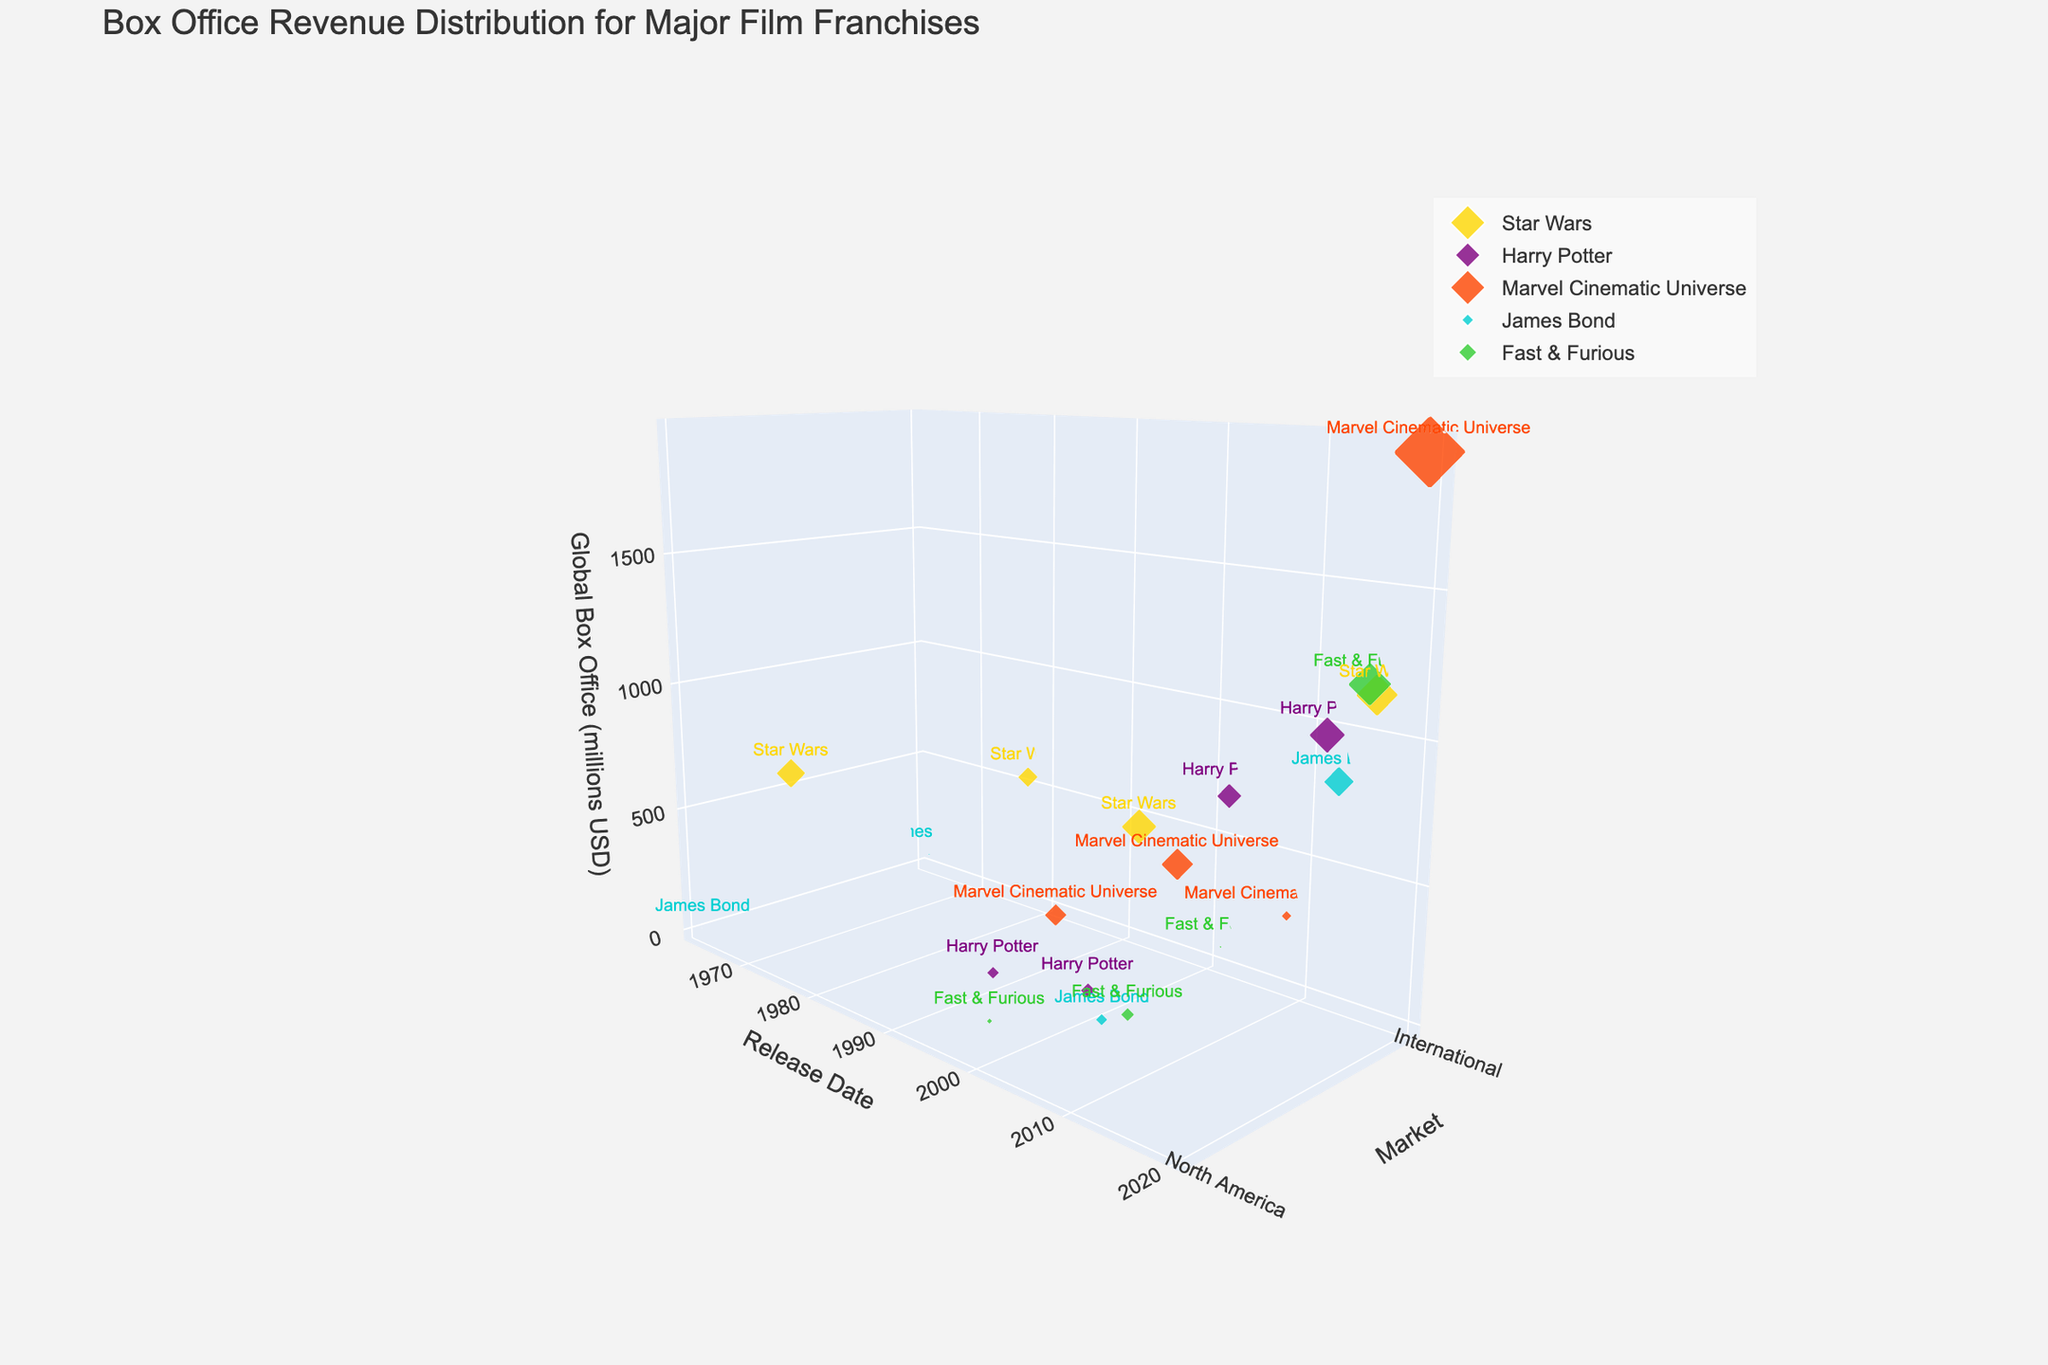What's the title of the figure? The title is typically placed at the top and is often larger than other text. It provides a summary of what the plot represents.
Answer: Box Office Revenue Distribution for Major Film Franchises What are the axes labels in the figure? The labels are usually placed next to the corresponding axes. They describe what each axis represents.
Answer: Release Date, Market, Global Box Office (millions USD) Which franchise has the highest global box office revenue in the "International" market based on the figure? By observing the 'z' axis (Global Box Office) and checking which franchise's marker reaches the highest point in the "International" market on the 'y' axis, we can determine this.
Answer: Marvel Cinematic Universe How many data points are there for "Harry Potter"? Each distinct marker in the plot represents a data point. Count the number of markers labeled "Harry Potter".
Answer: Four What is the color of the marker representing "Star Wars"? Each franchise has a distinct color for its markers. Check the figure legend or observe the color of "Star Wars" markers.
Answer: Gold Which franchise shows a significant jump in box office revenue between two different release dates? Look for franchises with markers at significantly different 'z' axis values between two dates on the 'x' axis. Compare these values to identify significant differences.
Answer: Star Wars Between "Fast & Furious" and "James Bond," which has a higher global box office revenue in North America in 2015? Focus on the 'z' axis values for the North American market in the year 2015 for both franchises. Compare these values to determine which is higher.
Answer: Fast & Furious In which market does the 2008 release of the "Marvel Cinematic Universe" have a lower box office revenue? Check the 'z' axis values for the 2008 release of Marvel Cinematic Universe in both North America and International markets and compare them.
Answer: International What is the difference in global box office revenue between the 1977 and 2015 releases of "Star Wars" in North America? Identify the 'z' axis values for Star Wars in North America for both years and subtract the 1977 value from the 2015 value.
Answer: 936 - 775 = 161 Which franchise has the largest marker size, indicating the highest revenue, in the entire plot? Identify the marker with the largest size, which typically corresponds to the highest 'z' axis (box office revenue) value, regardless of market or date.
Answer: Marvel Cinematic Universe 